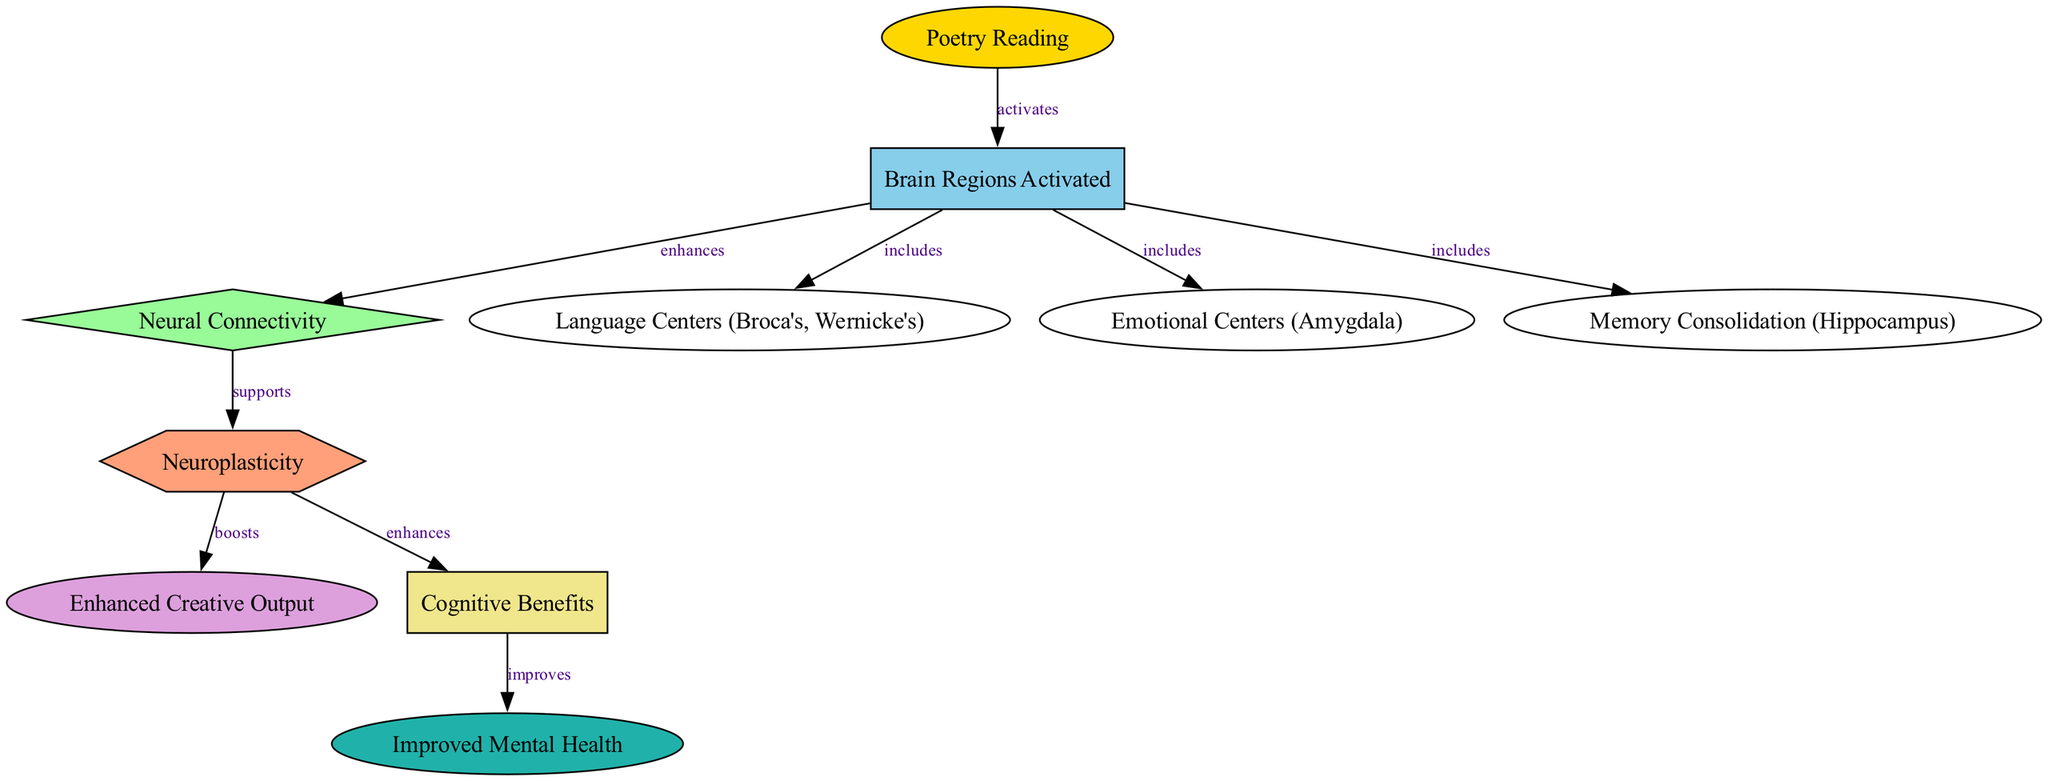What is the first node in the diagram? The first node in the diagram is "Poetry Reading," as it is the starting point from which other connections branch out.
Answer: Poetry Reading How many edges are there in the diagram? By counting the connections shown in the diagram, there are a total of 9 edges connecting various nodes.
Answer: 9 Which brain regions are activated by Poetry Reading? The brain regions activated by "Poetry Reading" include "Language Centers," "Emotional Centers," and "Memory Consolidation." This is indicated by the outgoing connections from the "Brain Regions Activated" node.
Answer: Language Centers, Emotional Centers, Memory Consolidation What does Neuroplasticity enhance? Neuroplasticity enhances "Creative Output" and "Cognitive Benefits," which are the two nodes directly connected to the "Neuroplasticity" node.
Answer: Creative Output, Cognitive Benefits What is the relationship between Cognitive Benefits and Mental Health? The relationship between "Cognitive Benefits" and "Mental Health" is that "Cognitive Benefits" improves "Mental Health," as demonstrated by the directed edge connecting these two nodes.
Answer: improves How does Connectivity relate to Neuroplasticity? Connectivity supports Neuroplasticity, meaning that enhanced connectivity in the brain is a factor that contributes to or promotes neuroplastic changes.
Answer: supports Which emotional center is activated by Poetry Reading? The emotional center activated by "Poetry Reading" is the "Amygdala," as indicated under the connections stemming from "Brain Regions Activated."
Answer: Amygdala Which node has the most connections stemming from it? The node that has the most connections stemming from it is "Brain Regions Activated," which connects to four other nodes, each representing different aspects of brain function.
Answer: Brain Regions Activated What role does Poetry Reading play in the diagram? Poetry Reading activates brain regions, leading to a cascade of effects on neural connectivity, neuroplasticity, and enhanced creative and cognitive outputs.
Answer: activates 